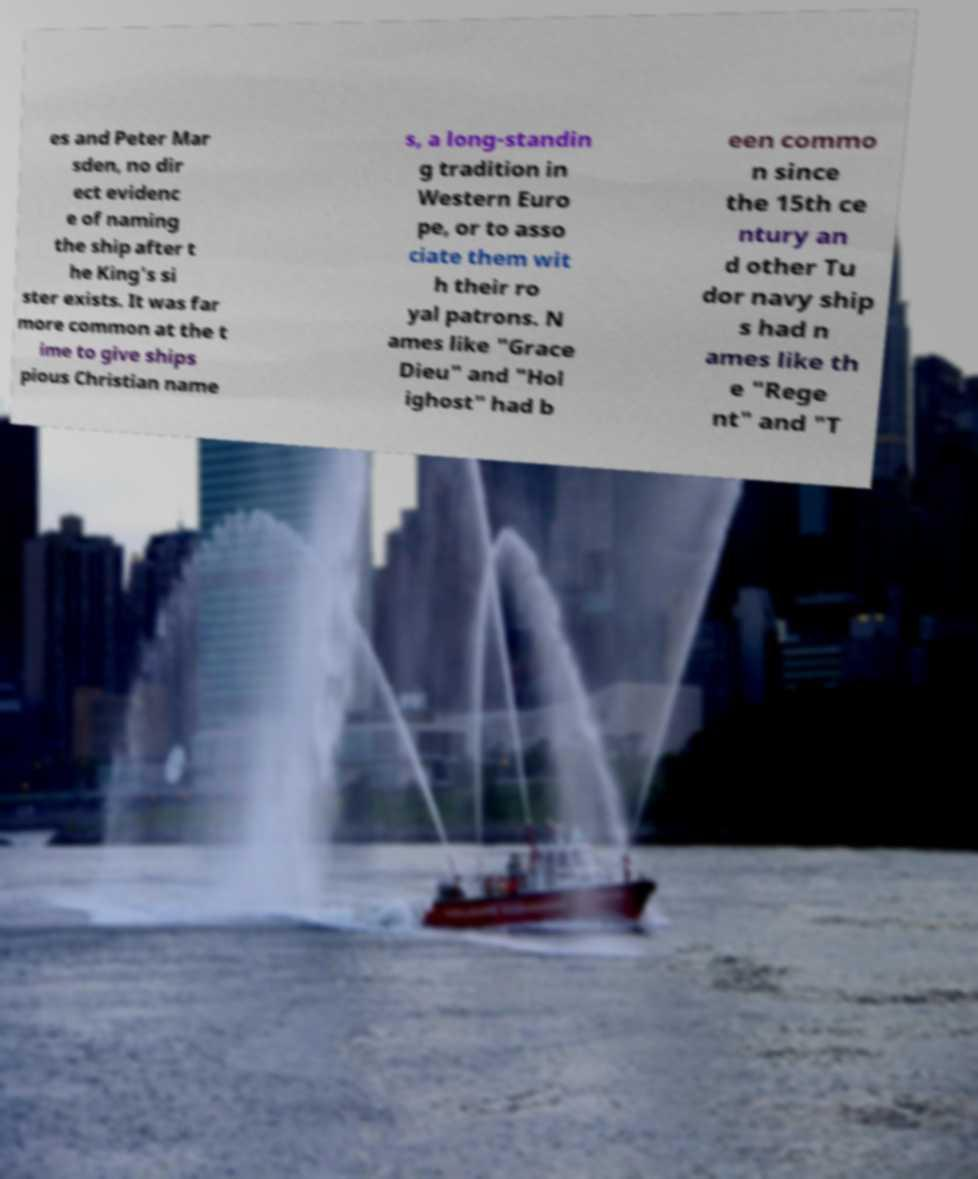Can you accurately transcribe the text from the provided image for me? es and Peter Mar sden, no dir ect evidenc e of naming the ship after t he King's si ster exists. It was far more common at the t ime to give ships pious Christian name s, a long-standin g tradition in Western Euro pe, or to asso ciate them wit h their ro yal patrons. N ames like "Grace Dieu" and "Hol ighost" had b een commo n since the 15th ce ntury an d other Tu dor navy ship s had n ames like th e "Rege nt" and "T 